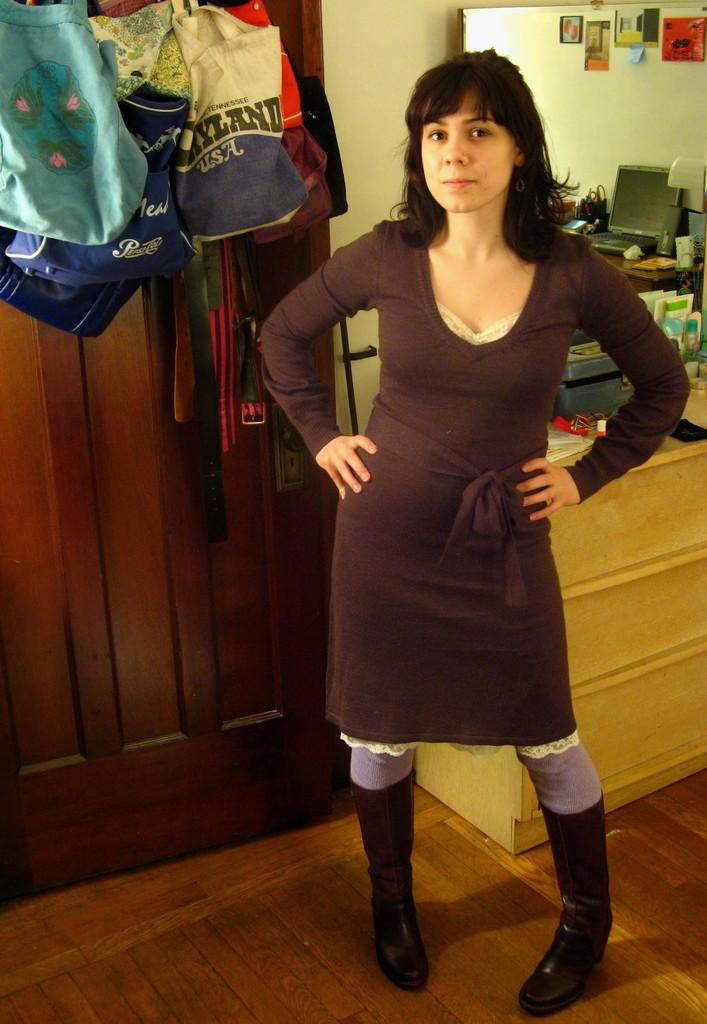<image>
Write a terse but informative summary of the picture. A woman stand defiantly in front of a collection of cloth bags, one of which has the words Pepsi Cola. 